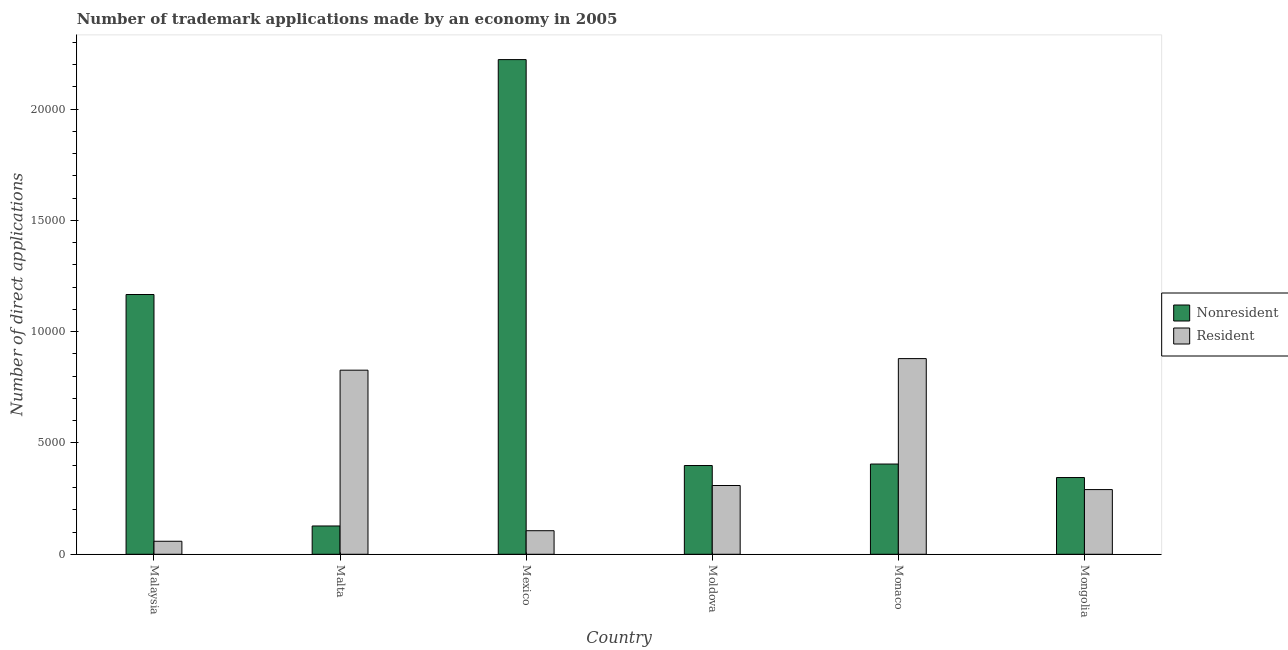How many different coloured bars are there?
Give a very brief answer. 2. How many groups of bars are there?
Provide a short and direct response. 6. Are the number of bars per tick equal to the number of legend labels?
Your answer should be very brief. Yes. What is the label of the 5th group of bars from the left?
Make the answer very short. Monaco. What is the number of trademark applications made by non residents in Monaco?
Offer a very short reply. 4053. Across all countries, what is the maximum number of trademark applications made by non residents?
Provide a short and direct response. 2.22e+04. Across all countries, what is the minimum number of trademark applications made by residents?
Give a very brief answer. 585. In which country was the number of trademark applications made by residents maximum?
Provide a succinct answer. Monaco. In which country was the number of trademark applications made by residents minimum?
Give a very brief answer. Malaysia. What is the total number of trademark applications made by residents in the graph?
Your answer should be compact. 2.47e+04. What is the difference between the number of trademark applications made by residents in Moldova and that in Monaco?
Your response must be concise. -5700. What is the difference between the number of trademark applications made by residents in Malta and the number of trademark applications made by non residents in Mongolia?
Make the answer very short. 4822. What is the average number of trademark applications made by residents per country?
Your response must be concise. 4116.17. What is the difference between the number of trademark applications made by residents and number of trademark applications made by non residents in Moldova?
Keep it short and to the point. -898. What is the ratio of the number of trademark applications made by non residents in Malta to that in Mongolia?
Keep it short and to the point. 0.37. Is the number of trademark applications made by non residents in Malta less than that in Monaco?
Offer a very short reply. Yes. What is the difference between the highest and the second highest number of trademark applications made by non residents?
Keep it short and to the point. 1.06e+04. What is the difference between the highest and the lowest number of trademark applications made by non residents?
Your response must be concise. 2.09e+04. In how many countries, is the number of trademark applications made by residents greater than the average number of trademark applications made by residents taken over all countries?
Make the answer very short. 2. What does the 1st bar from the left in Mongolia represents?
Keep it short and to the point. Nonresident. What does the 2nd bar from the right in Malaysia represents?
Your response must be concise. Nonresident. How many bars are there?
Make the answer very short. 12. What is the title of the graph?
Your response must be concise. Number of trademark applications made by an economy in 2005. What is the label or title of the Y-axis?
Provide a succinct answer. Number of direct applications. What is the Number of direct applications in Nonresident in Malaysia?
Keep it short and to the point. 1.17e+04. What is the Number of direct applications in Resident in Malaysia?
Provide a short and direct response. 585. What is the Number of direct applications in Nonresident in Malta?
Your answer should be very brief. 1271. What is the Number of direct applications in Resident in Malta?
Your answer should be very brief. 8269. What is the Number of direct applications of Nonresident in Mexico?
Offer a terse response. 2.22e+04. What is the Number of direct applications of Resident in Mexico?
Offer a very short reply. 1059. What is the Number of direct applications of Nonresident in Moldova?
Offer a terse response. 3987. What is the Number of direct applications in Resident in Moldova?
Offer a very short reply. 3089. What is the Number of direct applications in Nonresident in Monaco?
Your answer should be compact. 4053. What is the Number of direct applications of Resident in Monaco?
Your response must be concise. 8789. What is the Number of direct applications of Nonresident in Mongolia?
Provide a short and direct response. 3447. What is the Number of direct applications in Resident in Mongolia?
Provide a succinct answer. 2906. Across all countries, what is the maximum Number of direct applications in Nonresident?
Offer a very short reply. 2.22e+04. Across all countries, what is the maximum Number of direct applications in Resident?
Your answer should be very brief. 8789. Across all countries, what is the minimum Number of direct applications of Nonresident?
Your answer should be very brief. 1271. Across all countries, what is the minimum Number of direct applications in Resident?
Keep it short and to the point. 585. What is the total Number of direct applications in Nonresident in the graph?
Make the answer very short. 4.66e+04. What is the total Number of direct applications in Resident in the graph?
Your response must be concise. 2.47e+04. What is the difference between the Number of direct applications of Nonresident in Malaysia and that in Malta?
Make the answer very short. 1.04e+04. What is the difference between the Number of direct applications of Resident in Malaysia and that in Malta?
Provide a short and direct response. -7684. What is the difference between the Number of direct applications in Nonresident in Malaysia and that in Mexico?
Provide a succinct answer. -1.06e+04. What is the difference between the Number of direct applications of Resident in Malaysia and that in Mexico?
Your answer should be compact. -474. What is the difference between the Number of direct applications of Nonresident in Malaysia and that in Moldova?
Your response must be concise. 7681. What is the difference between the Number of direct applications in Resident in Malaysia and that in Moldova?
Offer a terse response. -2504. What is the difference between the Number of direct applications in Nonresident in Malaysia and that in Monaco?
Ensure brevity in your answer.  7615. What is the difference between the Number of direct applications of Resident in Malaysia and that in Monaco?
Offer a terse response. -8204. What is the difference between the Number of direct applications of Nonresident in Malaysia and that in Mongolia?
Your response must be concise. 8221. What is the difference between the Number of direct applications of Resident in Malaysia and that in Mongolia?
Ensure brevity in your answer.  -2321. What is the difference between the Number of direct applications of Nonresident in Malta and that in Mexico?
Provide a succinct answer. -2.09e+04. What is the difference between the Number of direct applications of Resident in Malta and that in Mexico?
Give a very brief answer. 7210. What is the difference between the Number of direct applications in Nonresident in Malta and that in Moldova?
Provide a succinct answer. -2716. What is the difference between the Number of direct applications of Resident in Malta and that in Moldova?
Your answer should be very brief. 5180. What is the difference between the Number of direct applications of Nonresident in Malta and that in Monaco?
Your response must be concise. -2782. What is the difference between the Number of direct applications in Resident in Malta and that in Monaco?
Ensure brevity in your answer.  -520. What is the difference between the Number of direct applications of Nonresident in Malta and that in Mongolia?
Ensure brevity in your answer.  -2176. What is the difference between the Number of direct applications in Resident in Malta and that in Mongolia?
Your answer should be compact. 5363. What is the difference between the Number of direct applications of Nonresident in Mexico and that in Moldova?
Your answer should be compact. 1.82e+04. What is the difference between the Number of direct applications of Resident in Mexico and that in Moldova?
Provide a succinct answer. -2030. What is the difference between the Number of direct applications of Nonresident in Mexico and that in Monaco?
Offer a very short reply. 1.82e+04. What is the difference between the Number of direct applications of Resident in Mexico and that in Monaco?
Make the answer very short. -7730. What is the difference between the Number of direct applications in Nonresident in Mexico and that in Mongolia?
Make the answer very short. 1.88e+04. What is the difference between the Number of direct applications in Resident in Mexico and that in Mongolia?
Offer a very short reply. -1847. What is the difference between the Number of direct applications of Nonresident in Moldova and that in Monaco?
Your answer should be compact. -66. What is the difference between the Number of direct applications in Resident in Moldova and that in Monaco?
Give a very brief answer. -5700. What is the difference between the Number of direct applications of Nonresident in Moldova and that in Mongolia?
Keep it short and to the point. 540. What is the difference between the Number of direct applications in Resident in Moldova and that in Mongolia?
Provide a short and direct response. 183. What is the difference between the Number of direct applications of Nonresident in Monaco and that in Mongolia?
Provide a short and direct response. 606. What is the difference between the Number of direct applications of Resident in Monaco and that in Mongolia?
Your answer should be very brief. 5883. What is the difference between the Number of direct applications in Nonresident in Malaysia and the Number of direct applications in Resident in Malta?
Your answer should be very brief. 3399. What is the difference between the Number of direct applications of Nonresident in Malaysia and the Number of direct applications of Resident in Mexico?
Provide a short and direct response. 1.06e+04. What is the difference between the Number of direct applications of Nonresident in Malaysia and the Number of direct applications of Resident in Moldova?
Offer a terse response. 8579. What is the difference between the Number of direct applications of Nonresident in Malaysia and the Number of direct applications of Resident in Monaco?
Your answer should be compact. 2879. What is the difference between the Number of direct applications in Nonresident in Malaysia and the Number of direct applications in Resident in Mongolia?
Make the answer very short. 8762. What is the difference between the Number of direct applications in Nonresident in Malta and the Number of direct applications in Resident in Mexico?
Your answer should be compact. 212. What is the difference between the Number of direct applications of Nonresident in Malta and the Number of direct applications of Resident in Moldova?
Offer a very short reply. -1818. What is the difference between the Number of direct applications in Nonresident in Malta and the Number of direct applications in Resident in Monaco?
Keep it short and to the point. -7518. What is the difference between the Number of direct applications of Nonresident in Malta and the Number of direct applications of Resident in Mongolia?
Keep it short and to the point. -1635. What is the difference between the Number of direct applications in Nonresident in Mexico and the Number of direct applications in Resident in Moldova?
Provide a succinct answer. 1.91e+04. What is the difference between the Number of direct applications of Nonresident in Mexico and the Number of direct applications of Resident in Monaco?
Offer a very short reply. 1.34e+04. What is the difference between the Number of direct applications of Nonresident in Mexico and the Number of direct applications of Resident in Mongolia?
Make the answer very short. 1.93e+04. What is the difference between the Number of direct applications of Nonresident in Moldova and the Number of direct applications of Resident in Monaco?
Keep it short and to the point. -4802. What is the difference between the Number of direct applications in Nonresident in Moldova and the Number of direct applications in Resident in Mongolia?
Provide a succinct answer. 1081. What is the difference between the Number of direct applications in Nonresident in Monaco and the Number of direct applications in Resident in Mongolia?
Offer a terse response. 1147. What is the average Number of direct applications of Nonresident per country?
Ensure brevity in your answer.  7774.17. What is the average Number of direct applications in Resident per country?
Offer a terse response. 4116.17. What is the difference between the Number of direct applications in Nonresident and Number of direct applications in Resident in Malaysia?
Your answer should be very brief. 1.11e+04. What is the difference between the Number of direct applications of Nonresident and Number of direct applications of Resident in Malta?
Ensure brevity in your answer.  -6998. What is the difference between the Number of direct applications of Nonresident and Number of direct applications of Resident in Mexico?
Offer a very short reply. 2.12e+04. What is the difference between the Number of direct applications of Nonresident and Number of direct applications of Resident in Moldova?
Offer a very short reply. 898. What is the difference between the Number of direct applications in Nonresident and Number of direct applications in Resident in Monaco?
Your answer should be very brief. -4736. What is the difference between the Number of direct applications in Nonresident and Number of direct applications in Resident in Mongolia?
Ensure brevity in your answer.  541. What is the ratio of the Number of direct applications of Nonresident in Malaysia to that in Malta?
Your answer should be compact. 9.18. What is the ratio of the Number of direct applications of Resident in Malaysia to that in Malta?
Offer a terse response. 0.07. What is the ratio of the Number of direct applications in Nonresident in Malaysia to that in Mexico?
Ensure brevity in your answer.  0.53. What is the ratio of the Number of direct applications in Resident in Malaysia to that in Mexico?
Offer a very short reply. 0.55. What is the ratio of the Number of direct applications of Nonresident in Malaysia to that in Moldova?
Keep it short and to the point. 2.93. What is the ratio of the Number of direct applications of Resident in Malaysia to that in Moldova?
Provide a succinct answer. 0.19. What is the ratio of the Number of direct applications in Nonresident in Malaysia to that in Monaco?
Keep it short and to the point. 2.88. What is the ratio of the Number of direct applications of Resident in Malaysia to that in Monaco?
Offer a very short reply. 0.07. What is the ratio of the Number of direct applications of Nonresident in Malaysia to that in Mongolia?
Keep it short and to the point. 3.38. What is the ratio of the Number of direct applications in Resident in Malaysia to that in Mongolia?
Provide a short and direct response. 0.2. What is the ratio of the Number of direct applications in Nonresident in Malta to that in Mexico?
Your answer should be very brief. 0.06. What is the ratio of the Number of direct applications of Resident in Malta to that in Mexico?
Provide a short and direct response. 7.81. What is the ratio of the Number of direct applications in Nonresident in Malta to that in Moldova?
Offer a very short reply. 0.32. What is the ratio of the Number of direct applications of Resident in Malta to that in Moldova?
Give a very brief answer. 2.68. What is the ratio of the Number of direct applications in Nonresident in Malta to that in Monaco?
Offer a very short reply. 0.31. What is the ratio of the Number of direct applications in Resident in Malta to that in Monaco?
Keep it short and to the point. 0.94. What is the ratio of the Number of direct applications of Nonresident in Malta to that in Mongolia?
Your response must be concise. 0.37. What is the ratio of the Number of direct applications of Resident in Malta to that in Mongolia?
Offer a very short reply. 2.85. What is the ratio of the Number of direct applications of Nonresident in Mexico to that in Moldova?
Offer a terse response. 5.57. What is the ratio of the Number of direct applications of Resident in Mexico to that in Moldova?
Keep it short and to the point. 0.34. What is the ratio of the Number of direct applications in Nonresident in Mexico to that in Monaco?
Your answer should be very brief. 5.48. What is the ratio of the Number of direct applications in Resident in Mexico to that in Monaco?
Offer a very short reply. 0.12. What is the ratio of the Number of direct applications of Nonresident in Mexico to that in Mongolia?
Ensure brevity in your answer.  6.45. What is the ratio of the Number of direct applications in Resident in Mexico to that in Mongolia?
Keep it short and to the point. 0.36. What is the ratio of the Number of direct applications of Nonresident in Moldova to that in Monaco?
Provide a succinct answer. 0.98. What is the ratio of the Number of direct applications of Resident in Moldova to that in Monaco?
Offer a very short reply. 0.35. What is the ratio of the Number of direct applications in Nonresident in Moldova to that in Mongolia?
Make the answer very short. 1.16. What is the ratio of the Number of direct applications in Resident in Moldova to that in Mongolia?
Make the answer very short. 1.06. What is the ratio of the Number of direct applications of Nonresident in Monaco to that in Mongolia?
Your answer should be very brief. 1.18. What is the ratio of the Number of direct applications of Resident in Monaco to that in Mongolia?
Your answer should be very brief. 3.02. What is the difference between the highest and the second highest Number of direct applications of Nonresident?
Offer a very short reply. 1.06e+04. What is the difference between the highest and the second highest Number of direct applications of Resident?
Provide a succinct answer. 520. What is the difference between the highest and the lowest Number of direct applications of Nonresident?
Your response must be concise. 2.09e+04. What is the difference between the highest and the lowest Number of direct applications in Resident?
Your answer should be very brief. 8204. 